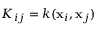Convert formula to latex. <formula><loc_0><loc_0><loc_500><loc_500>K _ { i j } = k ( x _ { i } , x _ { j } )</formula> 